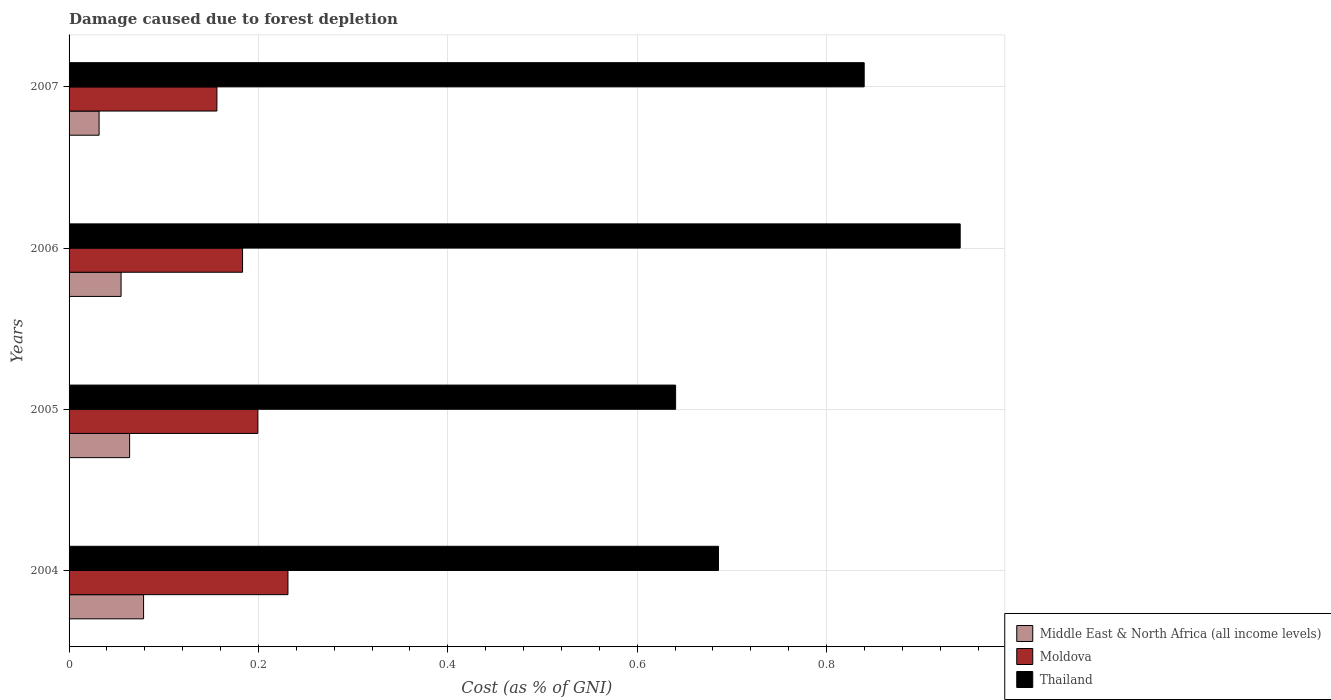How many different coloured bars are there?
Make the answer very short. 3. How many bars are there on the 3rd tick from the top?
Your answer should be compact. 3. In how many cases, is the number of bars for a given year not equal to the number of legend labels?
Offer a terse response. 0. What is the cost of damage caused due to forest depletion in Moldova in 2006?
Make the answer very short. 0.18. Across all years, what is the maximum cost of damage caused due to forest depletion in Thailand?
Offer a very short reply. 0.94. Across all years, what is the minimum cost of damage caused due to forest depletion in Thailand?
Offer a very short reply. 0.64. In which year was the cost of damage caused due to forest depletion in Middle East & North Africa (all income levels) maximum?
Provide a succinct answer. 2004. In which year was the cost of damage caused due to forest depletion in Moldova minimum?
Give a very brief answer. 2007. What is the total cost of damage caused due to forest depletion in Middle East & North Africa (all income levels) in the graph?
Offer a very short reply. 0.23. What is the difference between the cost of damage caused due to forest depletion in Moldova in 2004 and that in 2005?
Offer a very short reply. 0.03. What is the difference between the cost of damage caused due to forest depletion in Middle East & North Africa (all income levels) in 2006 and the cost of damage caused due to forest depletion in Thailand in 2007?
Give a very brief answer. -0.78. What is the average cost of damage caused due to forest depletion in Moldova per year?
Your answer should be very brief. 0.19. In the year 2007, what is the difference between the cost of damage caused due to forest depletion in Moldova and cost of damage caused due to forest depletion in Middle East & North Africa (all income levels)?
Your answer should be very brief. 0.12. In how many years, is the cost of damage caused due to forest depletion in Thailand greater than 0.28 %?
Provide a succinct answer. 4. What is the ratio of the cost of damage caused due to forest depletion in Thailand in 2005 to that in 2007?
Provide a succinct answer. 0.76. Is the cost of damage caused due to forest depletion in Moldova in 2005 less than that in 2007?
Your answer should be compact. No. What is the difference between the highest and the second highest cost of damage caused due to forest depletion in Moldova?
Ensure brevity in your answer.  0.03. What is the difference between the highest and the lowest cost of damage caused due to forest depletion in Moldova?
Offer a very short reply. 0.08. In how many years, is the cost of damage caused due to forest depletion in Middle East & North Africa (all income levels) greater than the average cost of damage caused due to forest depletion in Middle East & North Africa (all income levels) taken over all years?
Offer a very short reply. 2. What does the 2nd bar from the top in 2004 represents?
Your response must be concise. Moldova. What does the 2nd bar from the bottom in 2006 represents?
Provide a succinct answer. Moldova. How many bars are there?
Give a very brief answer. 12. Are all the bars in the graph horizontal?
Keep it short and to the point. Yes. Does the graph contain any zero values?
Give a very brief answer. No. Does the graph contain grids?
Your answer should be compact. Yes. Where does the legend appear in the graph?
Make the answer very short. Bottom right. How many legend labels are there?
Your answer should be compact. 3. How are the legend labels stacked?
Keep it short and to the point. Vertical. What is the title of the graph?
Offer a very short reply. Damage caused due to forest depletion. What is the label or title of the X-axis?
Your answer should be compact. Cost (as % of GNI). What is the label or title of the Y-axis?
Ensure brevity in your answer.  Years. What is the Cost (as % of GNI) of Middle East & North Africa (all income levels) in 2004?
Your answer should be compact. 0.08. What is the Cost (as % of GNI) in Moldova in 2004?
Provide a succinct answer. 0.23. What is the Cost (as % of GNI) of Thailand in 2004?
Your response must be concise. 0.69. What is the Cost (as % of GNI) of Middle East & North Africa (all income levels) in 2005?
Make the answer very short. 0.06. What is the Cost (as % of GNI) of Moldova in 2005?
Provide a succinct answer. 0.2. What is the Cost (as % of GNI) in Thailand in 2005?
Provide a succinct answer. 0.64. What is the Cost (as % of GNI) in Middle East & North Africa (all income levels) in 2006?
Ensure brevity in your answer.  0.05. What is the Cost (as % of GNI) in Moldova in 2006?
Ensure brevity in your answer.  0.18. What is the Cost (as % of GNI) in Thailand in 2006?
Make the answer very short. 0.94. What is the Cost (as % of GNI) of Middle East & North Africa (all income levels) in 2007?
Give a very brief answer. 0.03. What is the Cost (as % of GNI) in Moldova in 2007?
Your answer should be compact. 0.16. What is the Cost (as % of GNI) of Thailand in 2007?
Provide a succinct answer. 0.84. Across all years, what is the maximum Cost (as % of GNI) in Middle East & North Africa (all income levels)?
Ensure brevity in your answer.  0.08. Across all years, what is the maximum Cost (as % of GNI) of Moldova?
Your answer should be very brief. 0.23. Across all years, what is the maximum Cost (as % of GNI) of Thailand?
Offer a terse response. 0.94. Across all years, what is the minimum Cost (as % of GNI) in Middle East & North Africa (all income levels)?
Keep it short and to the point. 0.03. Across all years, what is the minimum Cost (as % of GNI) in Moldova?
Your answer should be very brief. 0.16. Across all years, what is the minimum Cost (as % of GNI) of Thailand?
Give a very brief answer. 0.64. What is the total Cost (as % of GNI) of Middle East & North Africa (all income levels) in the graph?
Your answer should be compact. 0.23. What is the total Cost (as % of GNI) in Moldova in the graph?
Provide a succinct answer. 0.77. What is the total Cost (as % of GNI) in Thailand in the graph?
Your answer should be very brief. 3.11. What is the difference between the Cost (as % of GNI) in Middle East & North Africa (all income levels) in 2004 and that in 2005?
Your answer should be compact. 0.01. What is the difference between the Cost (as % of GNI) in Moldova in 2004 and that in 2005?
Your response must be concise. 0.03. What is the difference between the Cost (as % of GNI) of Thailand in 2004 and that in 2005?
Your answer should be very brief. 0.05. What is the difference between the Cost (as % of GNI) of Middle East & North Africa (all income levels) in 2004 and that in 2006?
Your response must be concise. 0.02. What is the difference between the Cost (as % of GNI) in Moldova in 2004 and that in 2006?
Your answer should be very brief. 0.05. What is the difference between the Cost (as % of GNI) in Thailand in 2004 and that in 2006?
Provide a short and direct response. -0.26. What is the difference between the Cost (as % of GNI) in Middle East & North Africa (all income levels) in 2004 and that in 2007?
Your answer should be compact. 0.05. What is the difference between the Cost (as % of GNI) in Moldova in 2004 and that in 2007?
Offer a very short reply. 0.07. What is the difference between the Cost (as % of GNI) in Thailand in 2004 and that in 2007?
Your response must be concise. -0.15. What is the difference between the Cost (as % of GNI) of Middle East & North Africa (all income levels) in 2005 and that in 2006?
Make the answer very short. 0.01. What is the difference between the Cost (as % of GNI) of Moldova in 2005 and that in 2006?
Provide a succinct answer. 0.02. What is the difference between the Cost (as % of GNI) of Thailand in 2005 and that in 2006?
Provide a short and direct response. -0.3. What is the difference between the Cost (as % of GNI) of Middle East & North Africa (all income levels) in 2005 and that in 2007?
Ensure brevity in your answer.  0.03. What is the difference between the Cost (as % of GNI) of Moldova in 2005 and that in 2007?
Ensure brevity in your answer.  0.04. What is the difference between the Cost (as % of GNI) in Thailand in 2005 and that in 2007?
Offer a very short reply. -0.2. What is the difference between the Cost (as % of GNI) of Middle East & North Africa (all income levels) in 2006 and that in 2007?
Offer a very short reply. 0.02. What is the difference between the Cost (as % of GNI) in Moldova in 2006 and that in 2007?
Offer a terse response. 0.03. What is the difference between the Cost (as % of GNI) of Thailand in 2006 and that in 2007?
Offer a very short reply. 0.1. What is the difference between the Cost (as % of GNI) of Middle East & North Africa (all income levels) in 2004 and the Cost (as % of GNI) of Moldova in 2005?
Provide a succinct answer. -0.12. What is the difference between the Cost (as % of GNI) of Middle East & North Africa (all income levels) in 2004 and the Cost (as % of GNI) of Thailand in 2005?
Your answer should be compact. -0.56. What is the difference between the Cost (as % of GNI) in Moldova in 2004 and the Cost (as % of GNI) in Thailand in 2005?
Offer a very short reply. -0.41. What is the difference between the Cost (as % of GNI) of Middle East & North Africa (all income levels) in 2004 and the Cost (as % of GNI) of Moldova in 2006?
Offer a terse response. -0.1. What is the difference between the Cost (as % of GNI) of Middle East & North Africa (all income levels) in 2004 and the Cost (as % of GNI) of Thailand in 2006?
Offer a terse response. -0.86. What is the difference between the Cost (as % of GNI) of Moldova in 2004 and the Cost (as % of GNI) of Thailand in 2006?
Provide a succinct answer. -0.71. What is the difference between the Cost (as % of GNI) in Middle East & North Africa (all income levels) in 2004 and the Cost (as % of GNI) in Moldova in 2007?
Offer a very short reply. -0.08. What is the difference between the Cost (as % of GNI) of Middle East & North Africa (all income levels) in 2004 and the Cost (as % of GNI) of Thailand in 2007?
Your response must be concise. -0.76. What is the difference between the Cost (as % of GNI) of Moldova in 2004 and the Cost (as % of GNI) of Thailand in 2007?
Provide a succinct answer. -0.61. What is the difference between the Cost (as % of GNI) of Middle East & North Africa (all income levels) in 2005 and the Cost (as % of GNI) of Moldova in 2006?
Your answer should be very brief. -0.12. What is the difference between the Cost (as % of GNI) in Middle East & North Africa (all income levels) in 2005 and the Cost (as % of GNI) in Thailand in 2006?
Make the answer very short. -0.88. What is the difference between the Cost (as % of GNI) in Moldova in 2005 and the Cost (as % of GNI) in Thailand in 2006?
Give a very brief answer. -0.74. What is the difference between the Cost (as % of GNI) of Middle East & North Africa (all income levels) in 2005 and the Cost (as % of GNI) of Moldova in 2007?
Provide a succinct answer. -0.09. What is the difference between the Cost (as % of GNI) of Middle East & North Africa (all income levels) in 2005 and the Cost (as % of GNI) of Thailand in 2007?
Offer a terse response. -0.78. What is the difference between the Cost (as % of GNI) of Moldova in 2005 and the Cost (as % of GNI) of Thailand in 2007?
Offer a very short reply. -0.64. What is the difference between the Cost (as % of GNI) in Middle East & North Africa (all income levels) in 2006 and the Cost (as % of GNI) in Moldova in 2007?
Your response must be concise. -0.1. What is the difference between the Cost (as % of GNI) in Middle East & North Africa (all income levels) in 2006 and the Cost (as % of GNI) in Thailand in 2007?
Make the answer very short. -0.78. What is the difference between the Cost (as % of GNI) in Moldova in 2006 and the Cost (as % of GNI) in Thailand in 2007?
Provide a short and direct response. -0.66. What is the average Cost (as % of GNI) of Middle East & North Africa (all income levels) per year?
Keep it short and to the point. 0.06. What is the average Cost (as % of GNI) in Moldova per year?
Keep it short and to the point. 0.19. What is the average Cost (as % of GNI) of Thailand per year?
Offer a very short reply. 0.78. In the year 2004, what is the difference between the Cost (as % of GNI) of Middle East & North Africa (all income levels) and Cost (as % of GNI) of Moldova?
Your response must be concise. -0.15. In the year 2004, what is the difference between the Cost (as % of GNI) of Middle East & North Africa (all income levels) and Cost (as % of GNI) of Thailand?
Make the answer very short. -0.61. In the year 2004, what is the difference between the Cost (as % of GNI) in Moldova and Cost (as % of GNI) in Thailand?
Offer a very short reply. -0.45. In the year 2005, what is the difference between the Cost (as % of GNI) in Middle East & North Africa (all income levels) and Cost (as % of GNI) in Moldova?
Offer a terse response. -0.14. In the year 2005, what is the difference between the Cost (as % of GNI) in Middle East & North Africa (all income levels) and Cost (as % of GNI) in Thailand?
Your response must be concise. -0.58. In the year 2005, what is the difference between the Cost (as % of GNI) in Moldova and Cost (as % of GNI) in Thailand?
Your answer should be very brief. -0.44. In the year 2006, what is the difference between the Cost (as % of GNI) in Middle East & North Africa (all income levels) and Cost (as % of GNI) in Moldova?
Offer a terse response. -0.13. In the year 2006, what is the difference between the Cost (as % of GNI) in Middle East & North Africa (all income levels) and Cost (as % of GNI) in Thailand?
Your answer should be compact. -0.89. In the year 2006, what is the difference between the Cost (as % of GNI) in Moldova and Cost (as % of GNI) in Thailand?
Keep it short and to the point. -0.76. In the year 2007, what is the difference between the Cost (as % of GNI) in Middle East & North Africa (all income levels) and Cost (as % of GNI) in Moldova?
Give a very brief answer. -0.12. In the year 2007, what is the difference between the Cost (as % of GNI) in Middle East & North Africa (all income levels) and Cost (as % of GNI) in Thailand?
Provide a succinct answer. -0.81. In the year 2007, what is the difference between the Cost (as % of GNI) of Moldova and Cost (as % of GNI) of Thailand?
Your answer should be very brief. -0.68. What is the ratio of the Cost (as % of GNI) in Middle East & North Africa (all income levels) in 2004 to that in 2005?
Your answer should be compact. 1.23. What is the ratio of the Cost (as % of GNI) in Moldova in 2004 to that in 2005?
Your response must be concise. 1.16. What is the ratio of the Cost (as % of GNI) in Thailand in 2004 to that in 2005?
Offer a very short reply. 1.07. What is the ratio of the Cost (as % of GNI) in Middle East & North Africa (all income levels) in 2004 to that in 2006?
Ensure brevity in your answer.  1.43. What is the ratio of the Cost (as % of GNI) of Moldova in 2004 to that in 2006?
Offer a very short reply. 1.26. What is the ratio of the Cost (as % of GNI) of Thailand in 2004 to that in 2006?
Your answer should be very brief. 0.73. What is the ratio of the Cost (as % of GNI) of Middle East & North Africa (all income levels) in 2004 to that in 2007?
Your answer should be compact. 2.48. What is the ratio of the Cost (as % of GNI) in Moldova in 2004 to that in 2007?
Your response must be concise. 1.48. What is the ratio of the Cost (as % of GNI) in Thailand in 2004 to that in 2007?
Provide a succinct answer. 0.82. What is the ratio of the Cost (as % of GNI) of Middle East & North Africa (all income levels) in 2005 to that in 2006?
Offer a very short reply. 1.16. What is the ratio of the Cost (as % of GNI) of Moldova in 2005 to that in 2006?
Keep it short and to the point. 1.09. What is the ratio of the Cost (as % of GNI) in Thailand in 2005 to that in 2006?
Provide a succinct answer. 0.68. What is the ratio of the Cost (as % of GNI) in Middle East & North Africa (all income levels) in 2005 to that in 2007?
Offer a terse response. 2.02. What is the ratio of the Cost (as % of GNI) in Moldova in 2005 to that in 2007?
Your response must be concise. 1.28. What is the ratio of the Cost (as % of GNI) of Thailand in 2005 to that in 2007?
Make the answer very short. 0.76. What is the ratio of the Cost (as % of GNI) of Middle East & North Africa (all income levels) in 2006 to that in 2007?
Offer a terse response. 1.73. What is the ratio of the Cost (as % of GNI) of Moldova in 2006 to that in 2007?
Provide a succinct answer. 1.17. What is the ratio of the Cost (as % of GNI) in Thailand in 2006 to that in 2007?
Your answer should be compact. 1.12. What is the difference between the highest and the second highest Cost (as % of GNI) in Middle East & North Africa (all income levels)?
Your answer should be very brief. 0.01. What is the difference between the highest and the second highest Cost (as % of GNI) of Moldova?
Provide a succinct answer. 0.03. What is the difference between the highest and the second highest Cost (as % of GNI) of Thailand?
Give a very brief answer. 0.1. What is the difference between the highest and the lowest Cost (as % of GNI) in Middle East & North Africa (all income levels)?
Your answer should be compact. 0.05. What is the difference between the highest and the lowest Cost (as % of GNI) of Moldova?
Provide a succinct answer. 0.07. What is the difference between the highest and the lowest Cost (as % of GNI) in Thailand?
Your response must be concise. 0.3. 